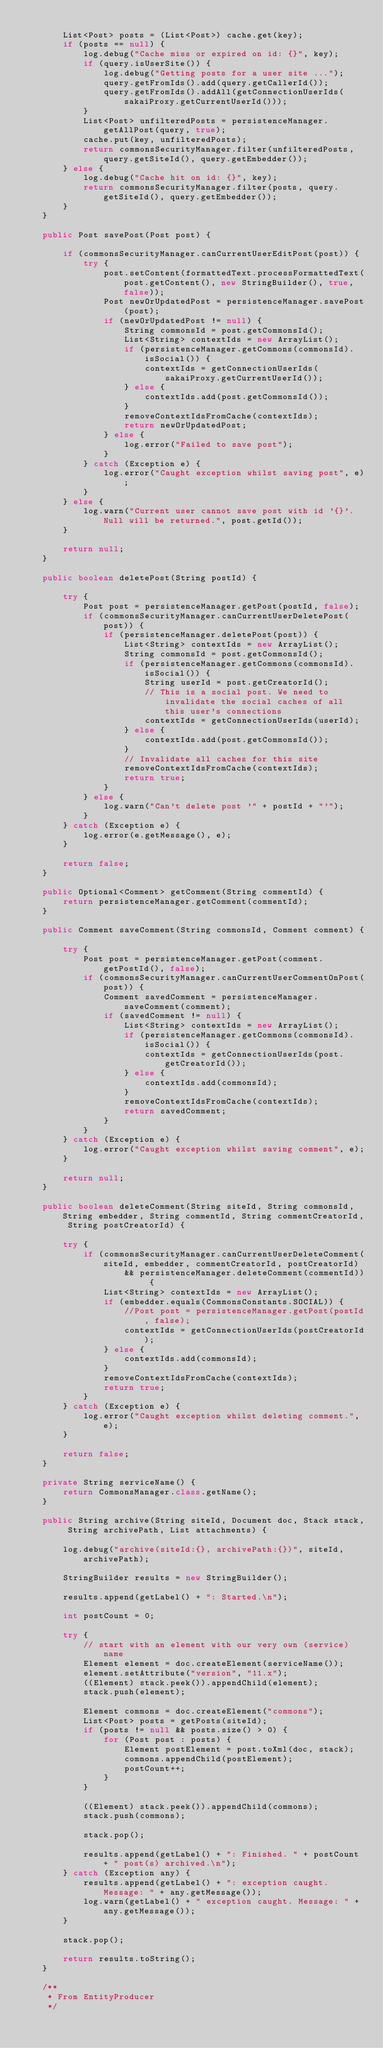Convert code to text. <code><loc_0><loc_0><loc_500><loc_500><_Java_>
        List<Post> posts = (List<Post>) cache.get(key);
        if (posts == null) {
            log.debug("Cache miss or expired on id: {}", key);
            if (query.isUserSite()) {
                log.debug("Getting posts for a user site ...");
                query.getFromIds().add(query.getCallerId());
                query.getFromIds().addAll(getConnectionUserIds(sakaiProxy.getCurrentUserId()));
            }
            List<Post> unfilteredPosts = persistenceManager.getAllPost(query, true);
            cache.put(key, unfilteredPosts);
            return commonsSecurityManager.filter(unfilteredPosts, query.getSiteId(), query.getEmbedder());
        } else {
            log.debug("Cache hit on id: {}", key);
            return commonsSecurityManager.filter(posts, query.getSiteId(), query.getEmbedder());
        }
    }

    public Post savePost(Post post) {

        if (commonsSecurityManager.canCurrentUserEditPost(post)) {
            try {
                post.setContent(formattedText.processFormattedText(post.getContent(), new StringBuilder(), true, false));
                Post newOrUpdatedPost = persistenceManager.savePost(post);
                if (newOrUpdatedPost != null) {
                    String commonsId = post.getCommonsId();
                    List<String> contextIds = new ArrayList();
                    if (persistenceManager.getCommons(commonsId).isSocial()) {
                        contextIds = getConnectionUserIds(sakaiProxy.getCurrentUserId());
                    } else {
                        contextIds.add(post.getCommonsId());
                    }
                    removeContextIdsFromCache(contextIds);
                    return newOrUpdatedPost;
                } else {
                    log.error("Failed to save post");
                }
            } catch (Exception e) {
                log.error("Caught exception whilst saving post", e);
            }
        } else {
            log.warn("Current user cannot save post with id '{}'. Null will be returned.", post.getId());
        }

        return null;
    }

    public boolean deletePost(String postId) {

        try {
            Post post = persistenceManager.getPost(postId, false);
            if (commonsSecurityManager.canCurrentUserDeletePost(post)) {
                if (persistenceManager.deletePost(post)) {
                    List<String> contextIds = new ArrayList();
                    String commonsId = post.getCommonsId();
                    if (persistenceManager.getCommons(commonsId).isSocial()) {
                        String userId = post.getCreatorId();
                        // This is a social post. We need to invalidate the social caches of all this user's connections
                        contextIds = getConnectionUserIds(userId);
                    } else {
                        contextIds.add(post.getCommonsId());
                    }
                    // Invalidate all caches for this site
                    removeContextIdsFromCache(contextIds);
                    return true;
                }
            } else {
                log.warn("Can't delete post '" + postId + "'");
            }
        } catch (Exception e) {
            log.error(e.getMessage(), e);
        }

        return false;
    }

    public Optional<Comment> getComment(String commentId) {
        return persistenceManager.getComment(commentId);
    }

    public Comment saveComment(String commonsId, Comment comment) {

        try {
            Post post = persistenceManager.getPost(comment.getPostId(), false);
            if (commonsSecurityManager.canCurrentUserCommentOnPost(post)) {
                Comment savedComment = persistenceManager.saveComment(comment);
                if (savedComment != null) {
                    List<String> contextIds = new ArrayList();
                    if (persistenceManager.getCommons(commonsId).isSocial()) {
                        contextIds = getConnectionUserIds(post.getCreatorId());
                    } else {
                        contextIds.add(commonsId);
                    }
                    removeContextIdsFromCache(contextIds);
                    return savedComment;
                }
            }
        } catch (Exception e) {
            log.error("Caught exception whilst saving comment", e);
        }

        return null;
    }

    public boolean deleteComment(String siteId, String commonsId, String embedder, String commentId, String commentCreatorId, String postCreatorId) {

        try {
            if (commonsSecurityManager.canCurrentUserDeleteComment(siteId, embedder, commentCreatorId, postCreatorId)
                    && persistenceManager.deleteComment(commentId)) {
                List<String> contextIds = new ArrayList();
                if (embedder.equals(CommonsConstants.SOCIAL)) {
                    //Post post = persistenceManager.getPost(postId, false);
                    contextIds = getConnectionUserIds(postCreatorId);
                } else {
                    contextIds.add(commonsId);
                }
                removeContextIdsFromCache(contextIds);
                return true;
            }
        } catch (Exception e) {
            log.error("Caught exception whilst deleting comment.", e);
        }

        return false;
    }

    private String serviceName() {
        return CommonsManager.class.getName();
    }

    public String archive(String siteId, Document doc, Stack stack, String archivePath, List attachments) {

        log.debug("archive(siteId:{}, archivePath:{})", siteId, archivePath);

        StringBuilder results = new StringBuilder();

        results.append(getLabel() + ": Started.\n");

        int postCount = 0;

        try {
            // start with an element with our very own (service) name
            Element element = doc.createElement(serviceName());
            element.setAttribute("version", "11.x");
            ((Element) stack.peek()).appendChild(element);
            stack.push(element);

            Element commons = doc.createElement("commons");
            List<Post> posts = getPosts(siteId);
            if (posts != null && posts.size() > 0) {
                for (Post post : posts) {
                    Element postElement = post.toXml(doc, stack);
                    commons.appendChild(postElement);
                    postCount++;
                }
            }

            ((Element) stack.peek()).appendChild(commons);
            stack.push(commons);

            stack.pop();

            results.append(getLabel() + ": Finished. " + postCount + " post(s) archived.\n");
        } catch (Exception any) {
            results.append(getLabel() + ": exception caught. Message: " + any.getMessage());
            log.warn(getLabel() + " exception caught. Message: " + any.getMessage());
        }

        stack.pop();

        return results.toString();
    }

    /**
     * From EntityProducer
     */</code> 